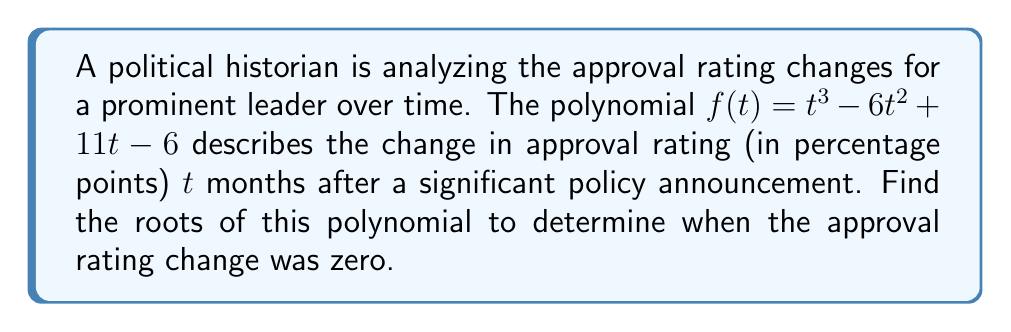Could you help me with this problem? To find the roots of the polynomial $f(t) = t^3 - 6t^2 + 11t - 6$, we need to factor it. Let's approach this step-by-step:

1) First, let's check if there are any rational roots using the rational root theorem. The possible rational roots are the factors of the constant term (6): $\pm1, \pm2, \pm3, \pm6$.

2) Testing these values, we find that $f(1) = 0$. So, $(t-1)$ is a factor.

3) We can use polynomial long division to divide $f(t)$ by $(t-1)$:

   $$t^3 - 6t^2 + 11t - 6 = (t-1)(t^2 - 5t + 6)$$

4) Now we need to factor the quadratic term $t^2 - 5t + 6$. We can do this by finding two numbers that multiply to give 6 and add to give -5. These numbers are -2 and -3.

5) Therefore, we can factor $t^2 - 5t + 6$ as $(t-2)(t-3)$.

6) Putting it all together, we have:

   $$f(t) = (t-1)(t-2)(t-3)$$

7) The roots of the polynomial are the values of $t$ that make each factor equal to zero. These are $t=1$, $t=2$, and $t=3$.

For the political historian, these roots indicate that the approval rating change was zero at 1 month, 2 months, and 3 months after the policy announcement.
Answer: The roots of the polynomial are $t=1$, $t=2$, and $t=3$. 